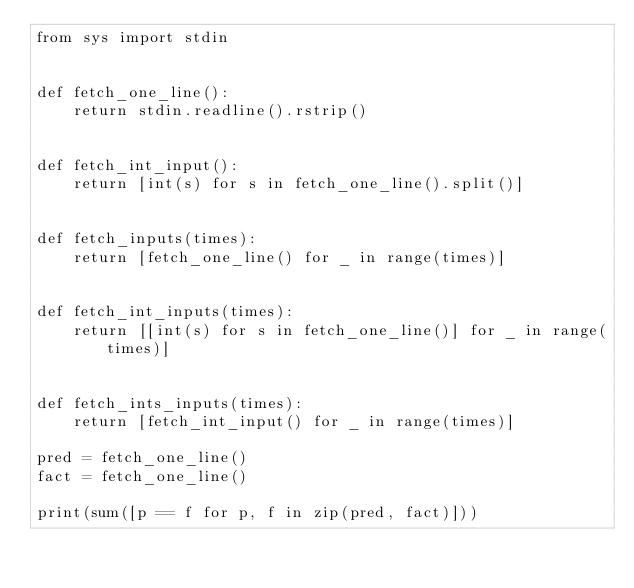Convert code to text. <code><loc_0><loc_0><loc_500><loc_500><_Python_>from sys import stdin


def fetch_one_line():
    return stdin.readline().rstrip()


def fetch_int_input():
    return [int(s) for s in fetch_one_line().split()]


def fetch_inputs(times):
    return [fetch_one_line() for _ in range(times)]


def fetch_int_inputs(times):
    return [[int(s) for s in fetch_one_line()] for _ in range(times)]


def fetch_ints_inputs(times):
    return [fetch_int_input() for _ in range(times)]

pred = fetch_one_line()
fact = fetch_one_line()

print(sum([p == f for p, f in zip(pred, fact)]))

</code> 